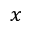<formula> <loc_0><loc_0><loc_500><loc_500>x</formula> 